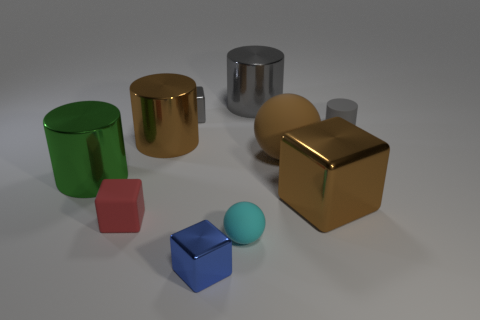Is the number of large brown matte objects greater than the number of rubber balls?
Provide a succinct answer. No. What is the shape of the rubber thing that is both right of the cyan rubber sphere and left of the gray matte thing?
Provide a short and direct response. Sphere. Are there any small cyan matte objects?
Provide a succinct answer. Yes. There is another gray object that is the same shape as the big gray object; what is its material?
Offer a terse response. Rubber. There is a object in front of the small cyan matte ball that is in front of the gray object behind the gray metal cube; what is its shape?
Offer a terse response. Cube. What is the material of the cube that is the same color as the tiny matte cylinder?
Give a very brief answer. Metal. What number of brown objects are the same shape as the tiny cyan thing?
Make the answer very short. 1. Do the cylinder behind the matte cylinder and the matte ball that is in front of the large brown cube have the same color?
Provide a succinct answer. No. There is a blue object that is the same size as the cyan rubber thing; what is it made of?
Provide a succinct answer. Metal. Is there a gray cylinder of the same size as the blue block?
Keep it short and to the point. Yes. 